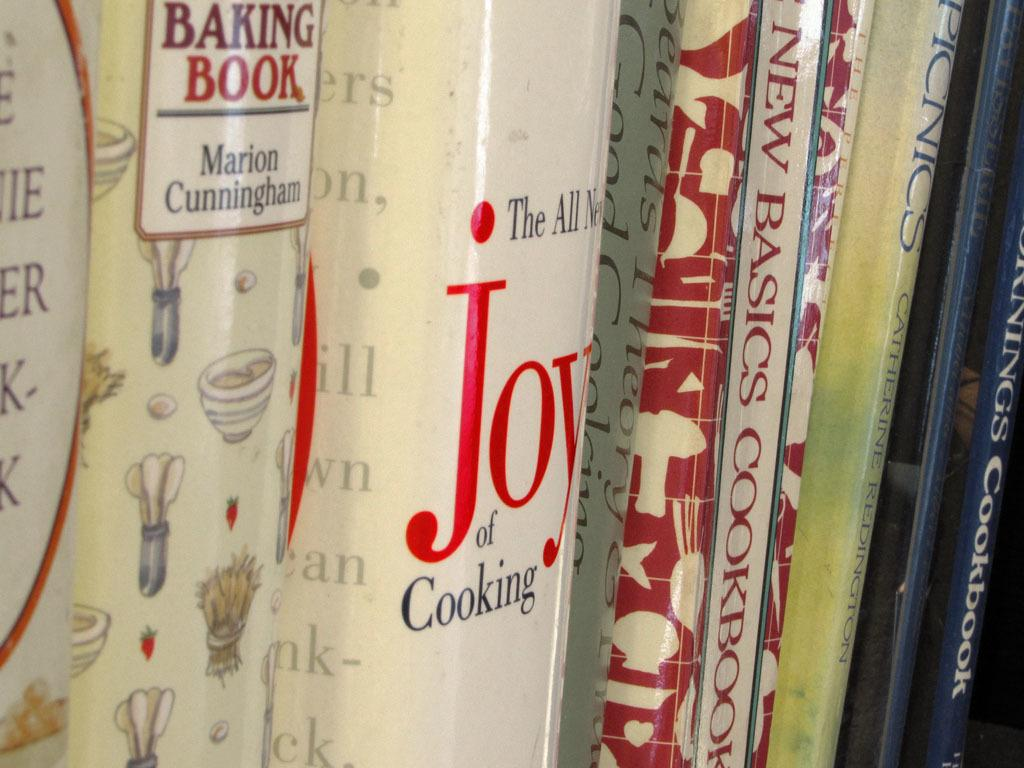<image>
Render a clear and concise summary of the photo. Several books are together, one of them is called Joy of cooking. 